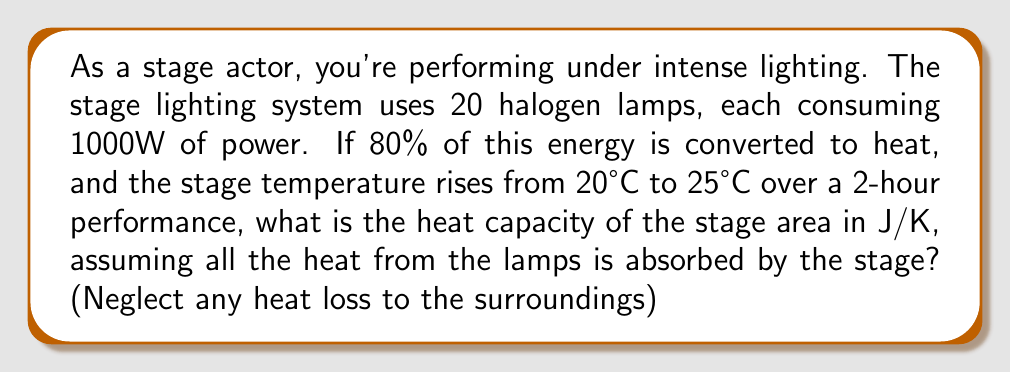Teach me how to tackle this problem. Let's approach this step-by-step:

1) First, calculate the total energy consumed by the lighting system:
   $$E_{total} = 20 \text{ lamps} \times 1000 \text{ W} \times 2 \text{ hours} \times 3600 \text{ s/hour} = 144,000,000 \text{ J}$$

2) Calculate the energy converted to heat:
   $$E_{heat} = 80\% \text{ of } E_{total} = 0.8 \times 144,000,000 \text{ J} = 115,200,000 \text{ J}$$

3) The temperature change is:
   $$\Delta T = 25°C - 20°C = 5°C = 5 \text{ K}$$

4) The heat capacity $C$ is defined as the energy required to raise the temperature by one degree:
   $$C = \frac{Q}{\Delta T}$$
   where $Q$ is the heat added and $\Delta T$ is the temperature change.

5) Substituting our values:
   $$C = \frac{115,200,000 \text{ J}}{5 \text{ K}} = 23,040,000 \text{ J/K}$$

Therefore, the heat capacity of the stage area is 23,040,000 J/K.
Answer: 23,040,000 J/K 